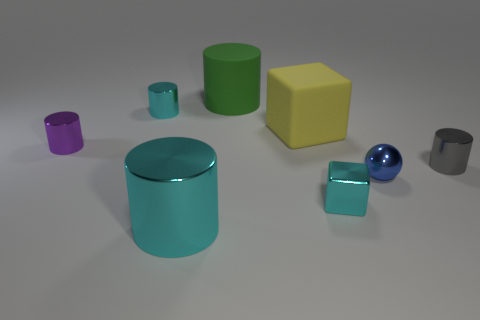Subtract all large cylinders. How many cylinders are left? 3 Subtract all purple cylinders. How many cylinders are left? 4 Subtract all red cylinders. Subtract all cyan spheres. How many cylinders are left? 5 Add 1 cyan metallic cubes. How many objects exist? 9 Subtract all balls. How many objects are left? 7 Subtract 1 blue balls. How many objects are left? 7 Subtract all small gray objects. Subtract all cyan cubes. How many objects are left? 6 Add 8 gray metal cylinders. How many gray metal cylinders are left? 9 Add 2 small blue shiny things. How many small blue shiny things exist? 3 